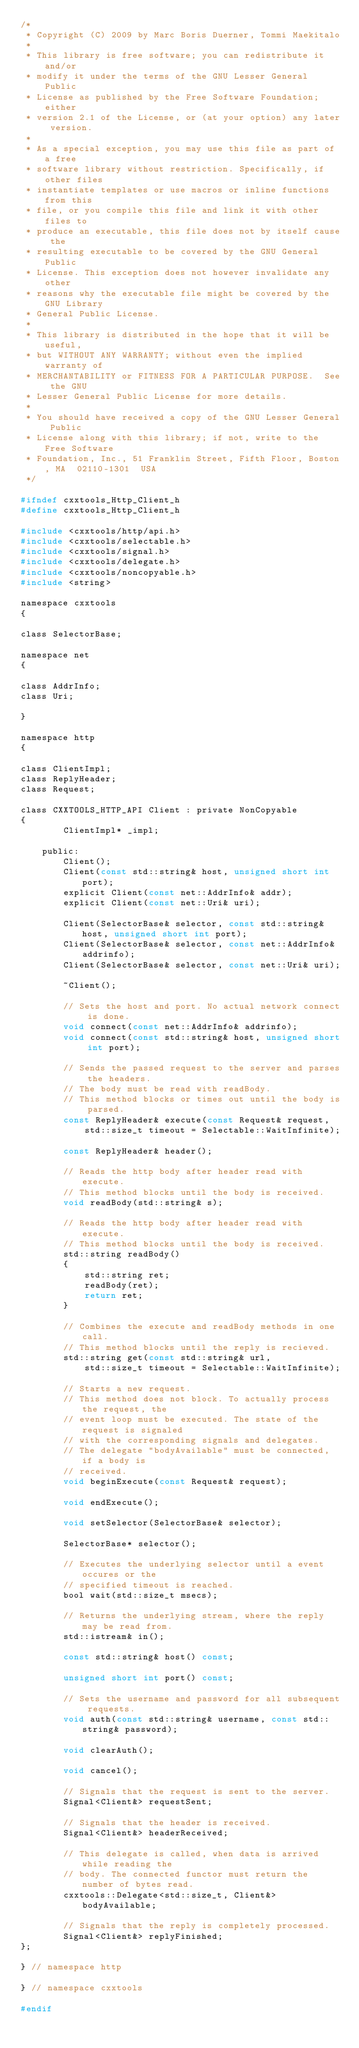<code> <loc_0><loc_0><loc_500><loc_500><_C_>/*
 * Copyright (C) 2009 by Marc Boris Duerner, Tommi Maekitalo
 * 
 * This library is free software; you can redistribute it and/or
 * modify it under the terms of the GNU Lesser General Public
 * License as published by the Free Software Foundation; either
 * version 2.1 of the License, or (at your option) any later version.
 * 
 * As a special exception, you may use this file as part of a free
 * software library without restriction. Specifically, if other files
 * instantiate templates or use macros or inline functions from this
 * file, or you compile this file and link it with other files to
 * produce an executable, this file does not by itself cause the
 * resulting executable to be covered by the GNU General Public
 * License. This exception does not however invalidate any other
 * reasons why the executable file might be covered by the GNU Library
 * General Public License.
 * 
 * This library is distributed in the hope that it will be useful,
 * but WITHOUT ANY WARRANTY; without even the implied warranty of
 * MERCHANTABILITY or FITNESS FOR A PARTICULAR PURPOSE.  See the GNU
 * Lesser General Public License for more details.
 * 
 * You should have received a copy of the GNU Lesser General Public
 * License along with this library; if not, write to the Free Software
 * Foundation, Inc., 51 Franklin Street, Fifth Floor, Boston, MA  02110-1301  USA
 */

#ifndef cxxtools_Http_Client_h
#define cxxtools_Http_Client_h

#include <cxxtools/http/api.h>
#include <cxxtools/selectable.h>
#include <cxxtools/signal.h>
#include <cxxtools/delegate.h>
#include <cxxtools/noncopyable.h>
#include <string>

namespace cxxtools
{

class SelectorBase;

namespace net
{

class AddrInfo;
class Uri;

}

namespace http
{

class ClientImpl;
class ReplyHeader;
class Request;

class CXXTOOLS_HTTP_API Client : private NonCopyable
{
        ClientImpl* _impl;

    public:
        Client();
        Client(const std::string& host, unsigned short int port);
        explicit Client(const net::AddrInfo& addr);
        explicit Client(const net::Uri& uri);

        Client(SelectorBase& selector, const std::string& host, unsigned short int port);
        Client(SelectorBase& selector, const net::AddrInfo& addrinfo);
        Client(SelectorBase& selector, const net::Uri& uri);

        ~Client();

        // Sets the host and port. No actual network connect is done.
        void connect(const net::AddrInfo& addrinfo);
        void connect(const std::string& host, unsigned short int port);

        // Sends the passed request to the server and parses the headers.
        // The body must be read with readBody.
        // This method blocks or times out until the body is parsed.
        const ReplyHeader& execute(const Request& request,
            std::size_t timeout = Selectable::WaitInfinite);

        const ReplyHeader& header();

        // Reads the http body after header read with execute.
        // This method blocks until the body is received.
        void readBody(std::string& s);

        // Reads the http body after header read with execute.
        // This method blocks until the body is received.
        std::string readBody()
        {
            std::string ret;
            readBody(ret);
            return ret;
        }

        // Combines the execute and readBody methods in one call.
        // This method blocks until the reply is recieved.
        std::string get(const std::string& url,
            std::size_t timeout = Selectable::WaitInfinite);

        // Starts a new request.
        // This method does not block. To actually process the request, the
        // event loop must be executed. The state of the request is signaled
        // with the corresponding signals and delegates.
        // The delegate "bodyAvailable" must be connected, if a body is
        // received.
        void beginExecute(const Request& request);

        void endExecute();

        void setSelector(SelectorBase& selector);

        SelectorBase* selector();

        // Executes the underlying selector until a event occures or the
        // specified timeout is reached.
        bool wait(std::size_t msecs);

        // Returns the underlying stream, where the reply may be read from.
        std::istream& in();

        const std::string& host() const;

        unsigned short int port() const;

        // Sets the username and password for all subsequent requests.
        void auth(const std::string& username, const std::string& password);

        void clearAuth();

        void cancel();

        // Signals that the request is sent to the server.
        Signal<Client&> requestSent;

        // Signals that the header is received.
        Signal<Client&> headerReceived;

        // This delegate is called, when data is arrived while reading the
        // body. The connected functor must return the number of bytes read.
        cxxtools::Delegate<std::size_t, Client&> bodyAvailable;

        // Signals that the reply is completely processed.
        Signal<Client&> replyFinished;
};

} // namespace http

} // namespace cxxtools

#endif
</code> 